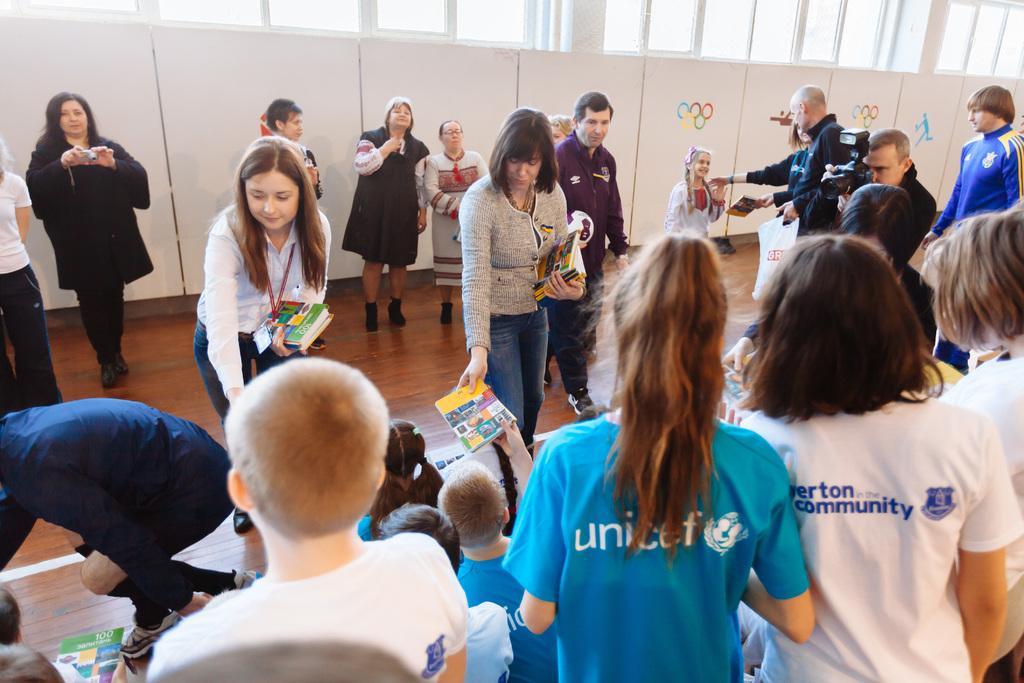How would you summarize this image in a sentence or two? In this image there are people standing and few are sitting, in the background there are posters on that posters there are symbols. 